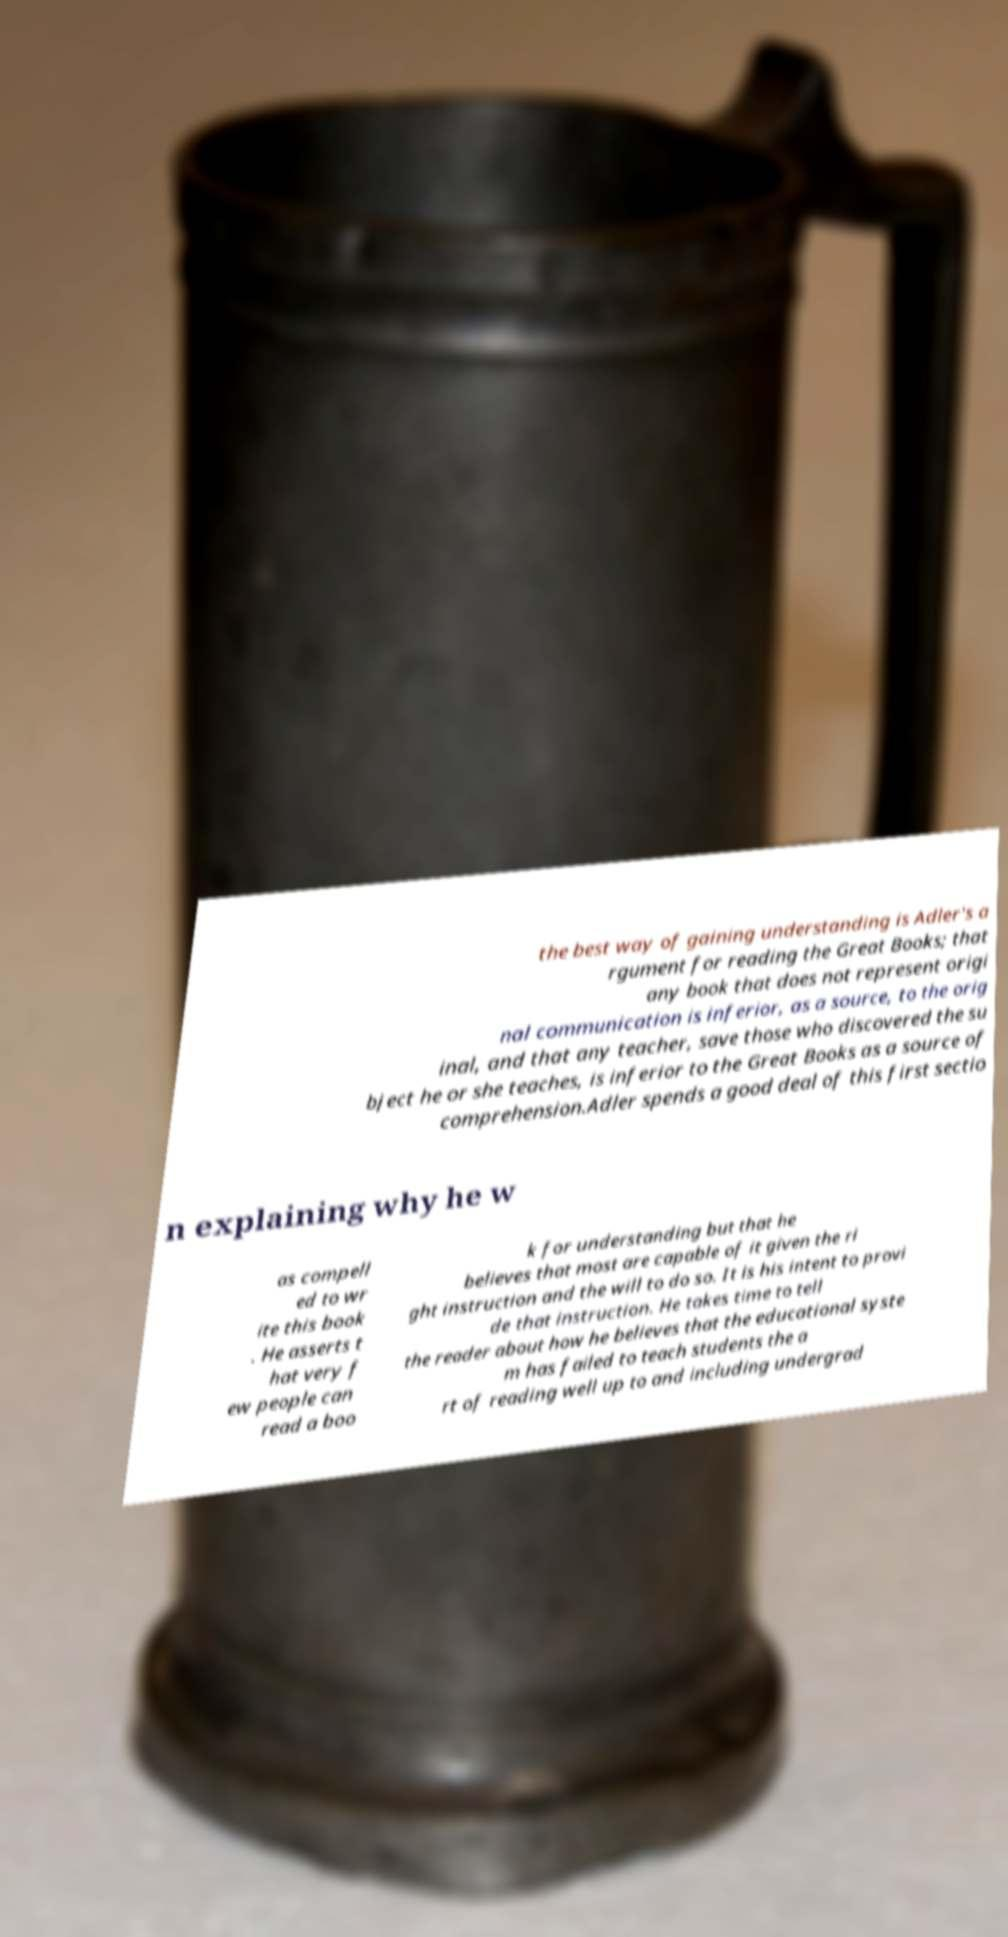Please identify and transcribe the text found in this image. the best way of gaining understanding is Adler's a rgument for reading the Great Books; that any book that does not represent origi nal communication is inferior, as a source, to the orig inal, and that any teacher, save those who discovered the su bject he or she teaches, is inferior to the Great Books as a source of comprehension.Adler spends a good deal of this first sectio n explaining why he w as compell ed to wr ite this book . He asserts t hat very f ew people can read a boo k for understanding but that he believes that most are capable of it given the ri ght instruction and the will to do so. It is his intent to provi de that instruction. He takes time to tell the reader about how he believes that the educational syste m has failed to teach students the a rt of reading well up to and including undergrad 